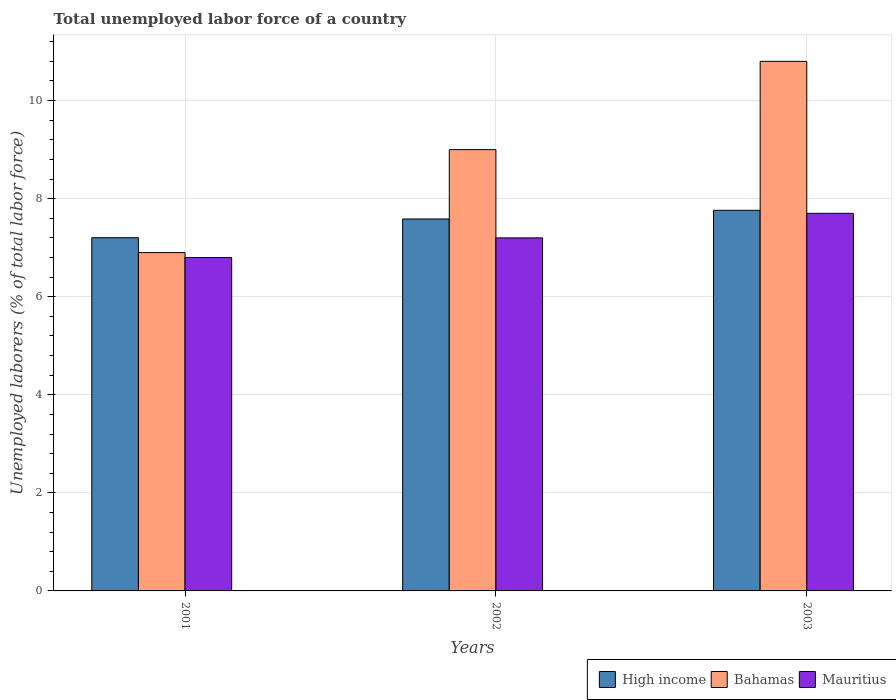How many different coloured bars are there?
Keep it short and to the point. 3. Are the number of bars on each tick of the X-axis equal?
Make the answer very short. Yes. How many bars are there on the 1st tick from the left?
Your response must be concise. 3. In how many cases, is the number of bars for a given year not equal to the number of legend labels?
Keep it short and to the point. 0. What is the total unemployed labor force in Bahamas in 2003?
Make the answer very short. 10.8. Across all years, what is the maximum total unemployed labor force in Mauritius?
Your response must be concise. 7.7. Across all years, what is the minimum total unemployed labor force in Bahamas?
Offer a terse response. 6.9. In which year was the total unemployed labor force in Mauritius minimum?
Your response must be concise. 2001. What is the total total unemployed labor force in Mauritius in the graph?
Offer a very short reply. 21.7. What is the difference between the total unemployed labor force in Mauritius in 2002 and that in 2003?
Your answer should be very brief. -0.5. What is the difference between the total unemployed labor force in High income in 2003 and the total unemployed labor force in Mauritius in 2002?
Offer a terse response. 0.56. What is the average total unemployed labor force in High income per year?
Provide a short and direct response. 7.52. In the year 2002, what is the difference between the total unemployed labor force in High income and total unemployed labor force in Mauritius?
Your response must be concise. 0.39. In how many years, is the total unemployed labor force in Mauritius greater than 1.2000000000000002 %?
Your response must be concise. 3. What is the ratio of the total unemployed labor force in Bahamas in 2001 to that in 2003?
Your answer should be compact. 0.64. Is the total unemployed labor force in High income in 2001 less than that in 2003?
Your answer should be very brief. Yes. Is the difference between the total unemployed labor force in High income in 2002 and 2003 greater than the difference between the total unemployed labor force in Mauritius in 2002 and 2003?
Offer a terse response. Yes. What is the difference between the highest and the second highest total unemployed labor force in Bahamas?
Provide a succinct answer. 1.8. What is the difference between the highest and the lowest total unemployed labor force in Bahamas?
Ensure brevity in your answer.  3.9. In how many years, is the total unemployed labor force in High income greater than the average total unemployed labor force in High income taken over all years?
Provide a succinct answer. 2. Is the sum of the total unemployed labor force in High income in 2002 and 2003 greater than the maximum total unemployed labor force in Mauritius across all years?
Your answer should be very brief. Yes. What does the 1st bar from the left in 2002 represents?
Offer a terse response. High income. Are all the bars in the graph horizontal?
Provide a short and direct response. No. How many years are there in the graph?
Offer a very short reply. 3. What is the difference between two consecutive major ticks on the Y-axis?
Give a very brief answer. 2. Where does the legend appear in the graph?
Offer a very short reply. Bottom right. How are the legend labels stacked?
Ensure brevity in your answer.  Horizontal. What is the title of the graph?
Provide a succinct answer. Total unemployed labor force of a country. Does "Venezuela" appear as one of the legend labels in the graph?
Ensure brevity in your answer.  No. What is the label or title of the Y-axis?
Your response must be concise. Unemployed laborers (% of total labor force). What is the Unemployed laborers (% of total labor force) of High income in 2001?
Your answer should be very brief. 7.2. What is the Unemployed laborers (% of total labor force) of Bahamas in 2001?
Provide a succinct answer. 6.9. What is the Unemployed laborers (% of total labor force) of Mauritius in 2001?
Your answer should be compact. 6.8. What is the Unemployed laborers (% of total labor force) of High income in 2002?
Your response must be concise. 7.59. What is the Unemployed laborers (% of total labor force) of Mauritius in 2002?
Ensure brevity in your answer.  7.2. What is the Unemployed laborers (% of total labor force) of High income in 2003?
Your answer should be compact. 7.76. What is the Unemployed laborers (% of total labor force) in Bahamas in 2003?
Offer a very short reply. 10.8. What is the Unemployed laborers (% of total labor force) of Mauritius in 2003?
Offer a very short reply. 7.7. Across all years, what is the maximum Unemployed laborers (% of total labor force) in High income?
Provide a short and direct response. 7.76. Across all years, what is the maximum Unemployed laborers (% of total labor force) in Bahamas?
Offer a very short reply. 10.8. Across all years, what is the maximum Unemployed laborers (% of total labor force) of Mauritius?
Offer a terse response. 7.7. Across all years, what is the minimum Unemployed laborers (% of total labor force) of High income?
Your answer should be very brief. 7.2. Across all years, what is the minimum Unemployed laborers (% of total labor force) of Bahamas?
Ensure brevity in your answer.  6.9. Across all years, what is the minimum Unemployed laborers (% of total labor force) of Mauritius?
Give a very brief answer. 6.8. What is the total Unemployed laborers (% of total labor force) of High income in the graph?
Ensure brevity in your answer.  22.55. What is the total Unemployed laborers (% of total labor force) in Bahamas in the graph?
Your answer should be compact. 26.7. What is the total Unemployed laborers (% of total labor force) of Mauritius in the graph?
Offer a terse response. 21.7. What is the difference between the Unemployed laborers (% of total labor force) in High income in 2001 and that in 2002?
Provide a succinct answer. -0.38. What is the difference between the Unemployed laborers (% of total labor force) in Bahamas in 2001 and that in 2002?
Offer a very short reply. -2.1. What is the difference between the Unemployed laborers (% of total labor force) of High income in 2001 and that in 2003?
Make the answer very short. -0.56. What is the difference between the Unemployed laborers (% of total labor force) in Bahamas in 2001 and that in 2003?
Your response must be concise. -3.9. What is the difference between the Unemployed laborers (% of total labor force) in Mauritius in 2001 and that in 2003?
Offer a terse response. -0.9. What is the difference between the Unemployed laborers (% of total labor force) in High income in 2002 and that in 2003?
Your response must be concise. -0.18. What is the difference between the Unemployed laborers (% of total labor force) of Mauritius in 2002 and that in 2003?
Your answer should be very brief. -0.5. What is the difference between the Unemployed laborers (% of total labor force) in High income in 2001 and the Unemployed laborers (% of total labor force) in Bahamas in 2002?
Ensure brevity in your answer.  -1.8. What is the difference between the Unemployed laborers (% of total labor force) of High income in 2001 and the Unemployed laborers (% of total labor force) of Mauritius in 2002?
Offer a terse response. 0. What is the difference between the Unemployed laborers (% of total labor force) in High income in 2001 and the Unemployed laborers (% of total labor force) in Bahamas in 2003?
Your response must be concise. -3.6. What is the difference between the Unemployed laborers (% of total labor force) in High income in 2001 and the Unemployed laborers (% of total labor force) in Mauritius in 2003?
Make the answer very short. -0.5. What is the difference between the Unemployed laborers (% of total labor force) in Bahamas in 2001 and the Unemployed laborers (% of total labor force) in Mauritius in 2003?
Make the answer very short. -0.8. What is the difference between the Unemployed laborers (% of total labor force) of High income in 2002 and the Unemployed laborers (% of total labor force) of Bahamas in 2003?
Ensure brevity in your answer.  -3.21. What is the difference between the Unemployed laborers (% of total labor force) of High income in 2002 and the Unemployed laborers (% of total labor force) of Mauritius in 2003?
Your answer should be compact. -0.11. What is the average Unemployed laborers (% of total labor force) in High income per year?
Your answer should be very brief. 7.52. What is the average Unemployed laborers (% of total labor force) of Mauritius per year?
Make the answer very short. 7.23. In the year 2001, what is the difference between the Unemployed laborers (% of total labor force) in High income and Unemployed laborers (% of total labor force) in Bahamas?
Offer a terse response. 0.3. In the year 2001, what is the difference between the Unemployed laborers (% of total labor force) of High income and Unemployed laborers (% of total labor force) of Mauritius?
Keep it short and to the point. 0.4. In the year 2001, what is the difference between the Unemployed laborers (% of total labor force) in Bahamas and Unemployed laborers (% of total labor force) in Mauritius?
Ensure brevity in your answer.  0.1. In the year 2002, what is the difference between the Unemployed laborers (% of total labor force) of High income and Unemployed laborers (% of total labor force) of Bahamas?
Keep it short and to the point. -1.41. In the year 2002, what is the difference between the Unemployed laborers (% of total labor force) in High income and Unemployed laborers (% of total labor force) in Mauritius?
Ensure brevity in your answer.  0.39. In the year 2002, what is the difference between the Unemployed laborers (% of total labor force) of Bahamas and Unemployed laborers (% of total labor force) of Mauritius?
Provide a succinct answer. 1.8. In the year 2003, what is the difference between the Unemployed laborers (% of total labor force) of High income and Unemployed laborers (% of total labor force) of Bahamas?
Make the answer very short. -3.04. In the year 2003, what is the difference between the Unemployed laborers (% of total labor force) in High income and Unemployed laborers (% of total labor force) in Mauritius?
Give a very brief answer. 0.06. What is the ratio of the Unemployed laborers (% of total labor force) in High income in 2001 to that in 2002?
Give a very brief answer. 0.95. What is the ratio of the Unemployed laborers (% of total labor force) of Bahamas in 2001 to that in 2002?
Give a very brief answer. 0.77. What is the ratio of the Unemployed laborers (% of total labor force) of High income in 2001 to that in 2003?
Your answer should be compact. 0.93. What is the ratio of the Unemployed laborers (% of total labor force) in Bahamas in 2001 to that in 2003?
Offer a terse response. 0.64. What is the ratio of the Unemployed laborers (% of total labor force) in Mauritius in 2001 to that in 2003?
Your response must be concise. 0.88. What is the ratio of the Unemployed laborers (% of total labor force) of High income in 2002 to that in 2003?
Keep it short and to the point. 0.98. What is the ratio of the Unemployed laborers (% of total labor force) in Bahamas in 2002 to that in 2003?
Give a very brief answer. 0.83. What is the ratio of the Unemployed laborers (% of total labor force) of Mauritius in 2002 to that in 2003?
Make the answer very short. 0.94. What is the difference between the highest and the second highest Unemployed laborers (% of total labor force) of High income?
Keep it short and to the point. 0.18. What is the difference between the highest and the lowest Unemployed laborers (% of total labor force) of High income?
Ensure brevity in your answer.  0.56. What is the difference between the highest and the lowest Unemployed laborers (% of total labor force) in Bahamas?
Give a very brief answer. 3.9. 